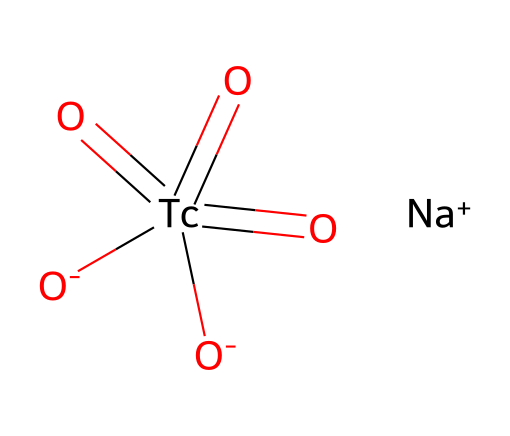What is the main element present in this chemical? The main element in this chemical is Technetium, as indicated by the symbol "Tc" in the chemical structure.
Answer: Technetium How many oxygen atoms are present in this structure? The chemical contains four oxygen atoms, which can be identified by counting the "[O]" symbols in the SMILES notation.
Answer: four What charge does the sodium ion carry in this compound? The sodium ion is represented as "[Na+]", indicating that it has a positive charge of +1.
Answer: +1 What type of chemical compound is this involved in medical imaging? The chemical is a radioactive isotope used in medical imaging, specifically as a radiotracer in diagnostic procedures.
Answer: radioactive isotope How many total atoms are there in this chemical? To determine the total number of atoms, we count the number of elements: 1 sodium (Na), 1 technetium (Tc), and 4 oxygens (O), resulting in a total of 6 atoms.
Answer: six What is the oxidation state of technetium in this compound? In the chemical structure, technetium (Tc) is in the +7 oxidation state, as inferred from its bonding to four oxygen atoms, which typically have a -2 oxidation state each, balanced by the Tc atom.
Answer: +7 